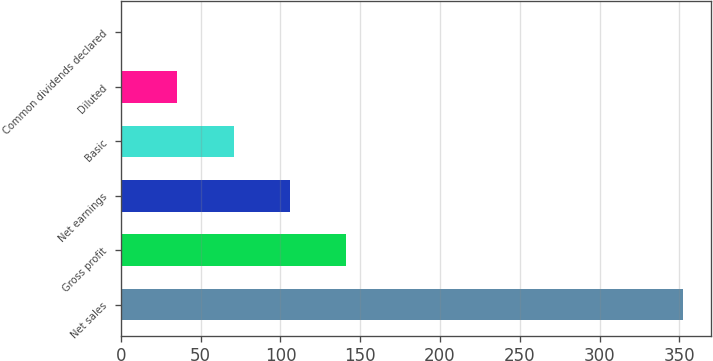<chart> <loc_0><loc_0><loc_500><loc_500><bar_chart><fcel>Net sales<fcel>Gross profit<fcel>Net earnings<fcel>Basic<fcel>Diluted<fcel>Common dividends declared<nl><fcel>352.4<fcel>141.06<fcel>105.83<fcel>70.6<fcel>35.37<fcel>0.14<nl></chart> 